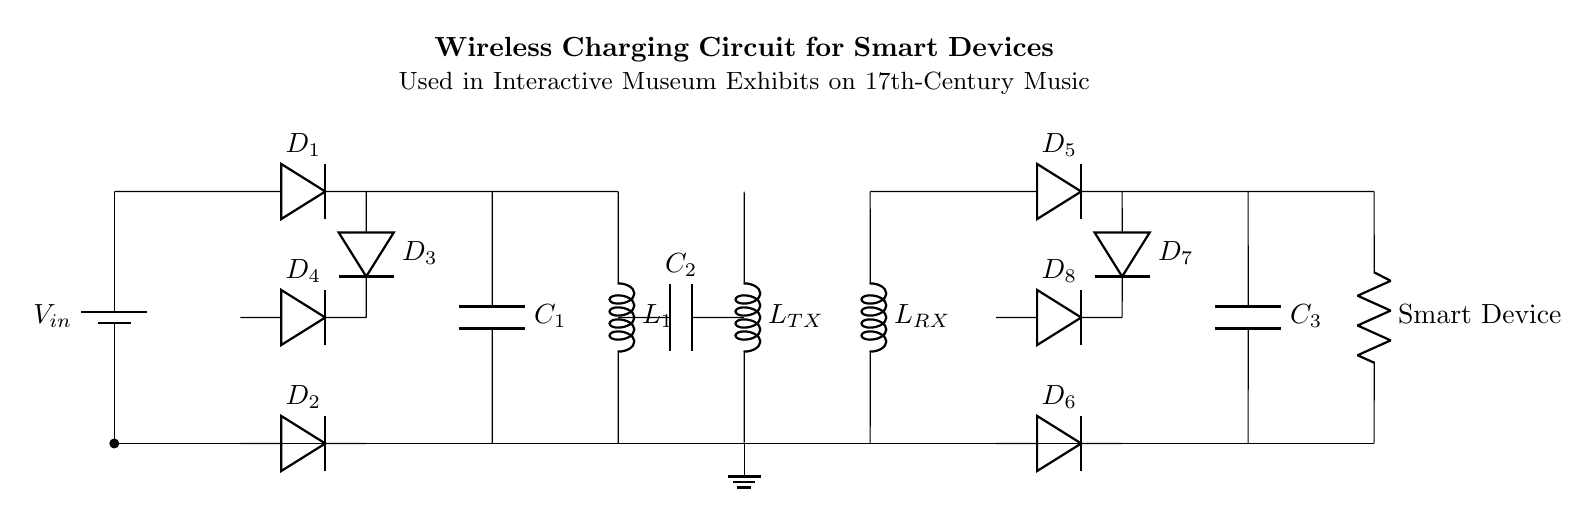What is the type of capacitors used in this circuit? There are two capacitors in the circuit: C1 and C3. Both are smoothing/output capacitors used to stabilize the voltage and filter the output to the smart device.
Answer: capacitors How many diodes are present in this circuit? The circuit has a total of eight diodes labeled D1, D2, D3, D4, D5, D6, D7, and D8. They are used for rectification in both the power supply and the receiver circuit for the smart device.
Answer: eight What is the purpose of the inductor labeled L_TX? The inductor L_TX acts as a transmitter coil, creating a magnetic field to wirelessly transfer power to the receiver coil (L_RX) located in the smart device.
Answer: magnetic field Which component smooths the output voltage to the smart device? C3 is the output capacitor that smooths the voltage supplied to the smart device, ensuring stable operation by filtering out any fluctuations in the voltage.
Answer: C3 What would happen if the rectifiers failed? If the rectifiers (diodes D1 through D8) failed, the circuit would not effectively convert the AC voltage to DC, which would prevent the smart device from charging properly.
Answer: charging failure What is the role of the inductor labeled L_RX in the circuit? L_RX is the receiver coil that absorbs the magnetic energy transmitted from L_TX, converting it back into electrical energy to charge the smart device.
Answer: energy absorption What is the voltage source in this circuit? The voltage source is labeled V_in at the top of the circuit diagram, providing the initial power necessary to start the charging process.
Answer: V_in 